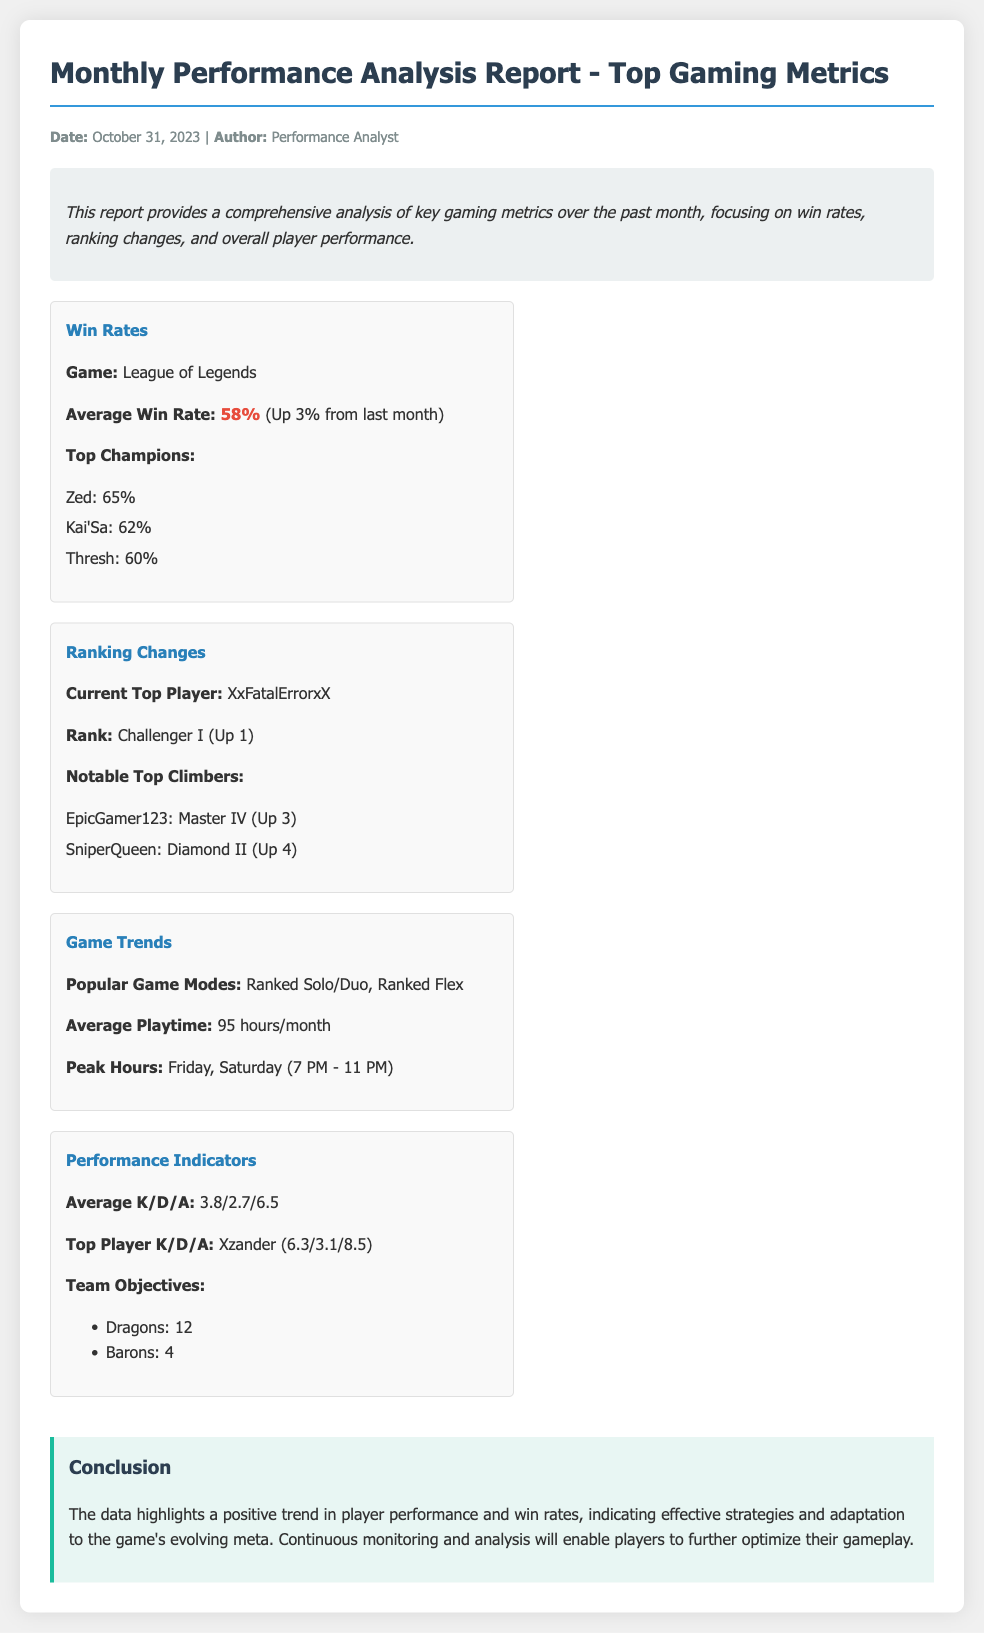What is the average win rate for League of Legends? The average win rate for League of Legends is stated as 58%, with a comparison to last month denoting an increase of 3%.
Answer: 58% Who is the current top player mentioned in the report? The report specifies the current top player as XxFatalErrorxX.
Answer: XxFatalErrorxX What is the rank change for the current top player? The document notes that the current top player is Challenger I and has moved up by 1 rank.
Answer: Up 1 What is the average playtime mentioned in the report? The report indicates the average playtime as 95 hours per month.
Answer: 95 hours/month Which game modes are listed as popular? The popular game modes highlighted in the report are Ranked Solo/Duo and Ranked Flex.
Answer: Ranked Solo/Duo, Ranked Flex What was the top player's K/D/A? The top player's K/D/A mentioned in the report is 6.3/3.1/8.5.
Answer: 6.3/3.1/8.5 How many Dragons were secured according to the performance indicators? The document states that 12 Dragons were secured as part of the team objectives.
Answer: 12 What is the date of the report? The memo states the date as October 31, 2023.
Answer: October 31, 2023 What trend is highlighted in the conclusion? The conclusion highlights a positive trend in player performance and win rates.
Answer: Positive trend 